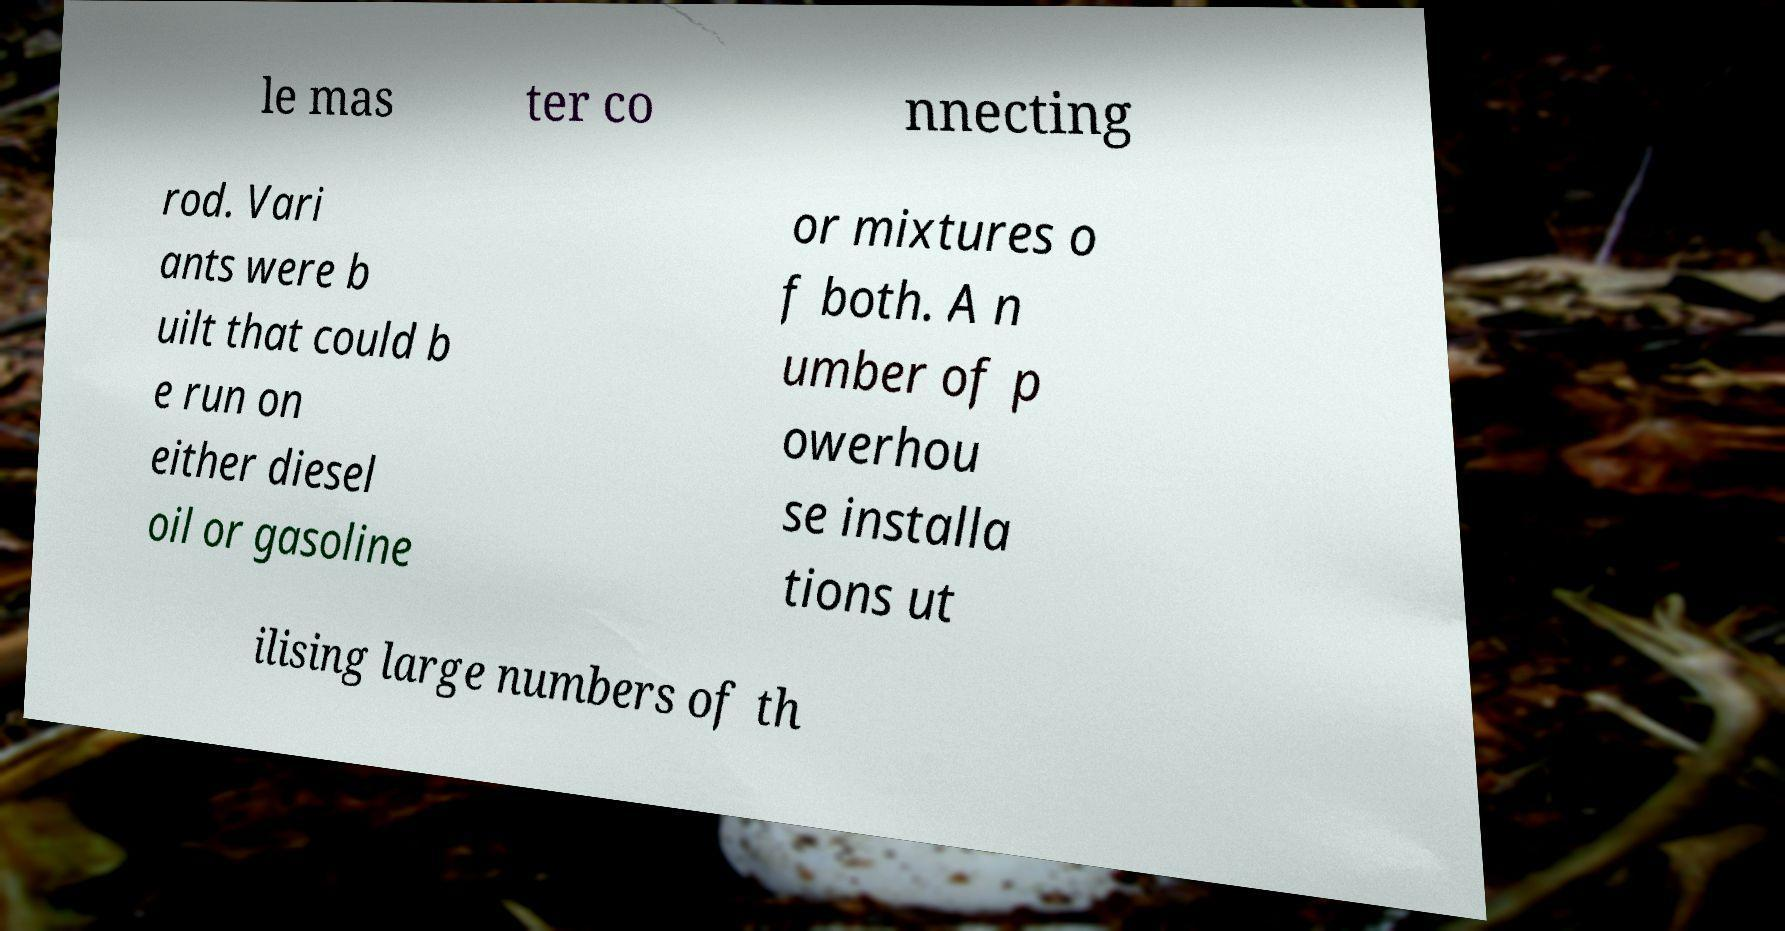For documentation purposes, I need the text within this image transcribed. Could you provide that? le mas ter co nnecting rod. Vari ants were b uilt that could b e run on either diesel oil or gasoline or mixtures o f both. A n umber of p owerhou se installa tions ut ilising large numbers of th 